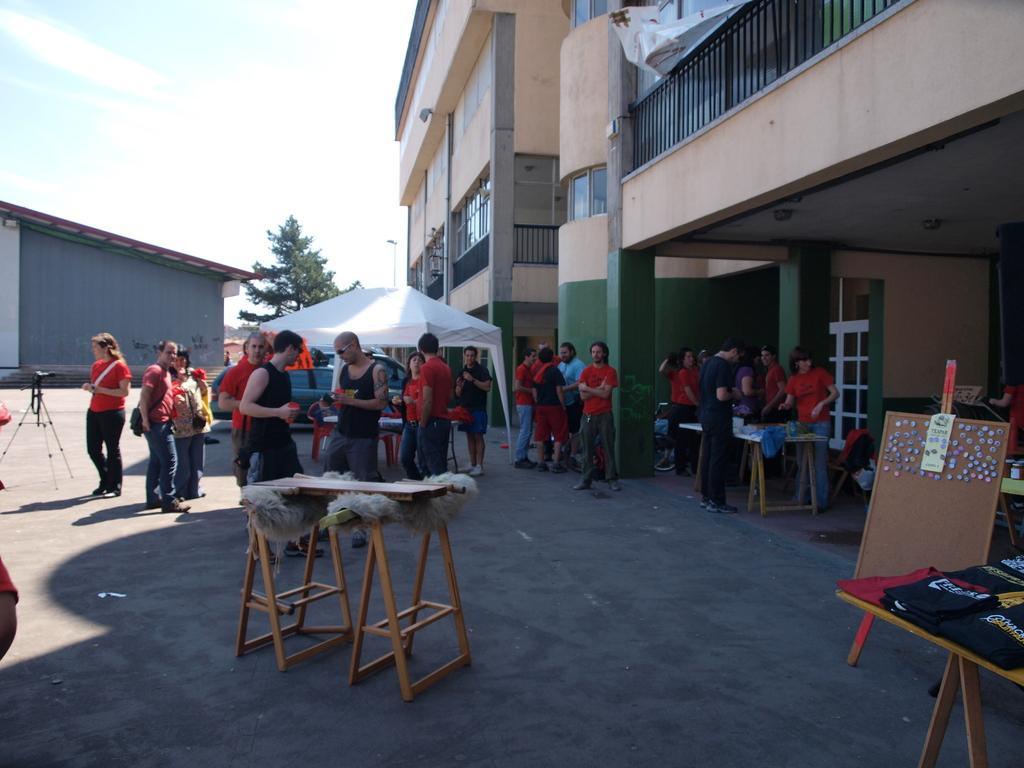Could you give a brief overview of what you see in this image? In the picture we can see a group of people wearing a red T-shirts. And in the background we can find a sky, tree, house, and some buildings with railings, doors and pillars. And we can also find some tables and board. 